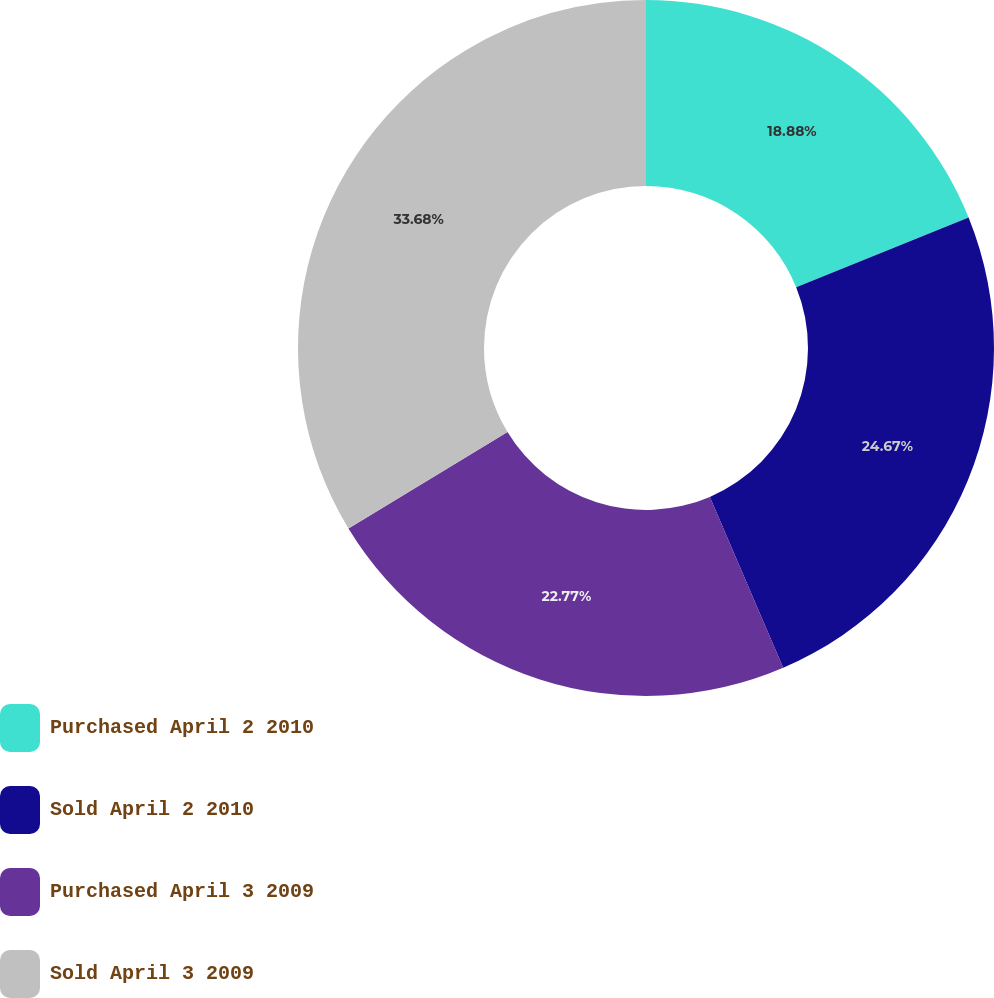Convert chart. <chart><loc_0><loc_0><loc_500><loc_500><pie_chart><fcel>Purchased April 2 2010<fcel>Sold April 2 2010<fcel>Purchased April 3 2009<fcel>Sold April 3 2009<nl><fcel>18.88%<fcel>24.67%<fcel>22.77%<fcel>33.68%<nl></chart> 